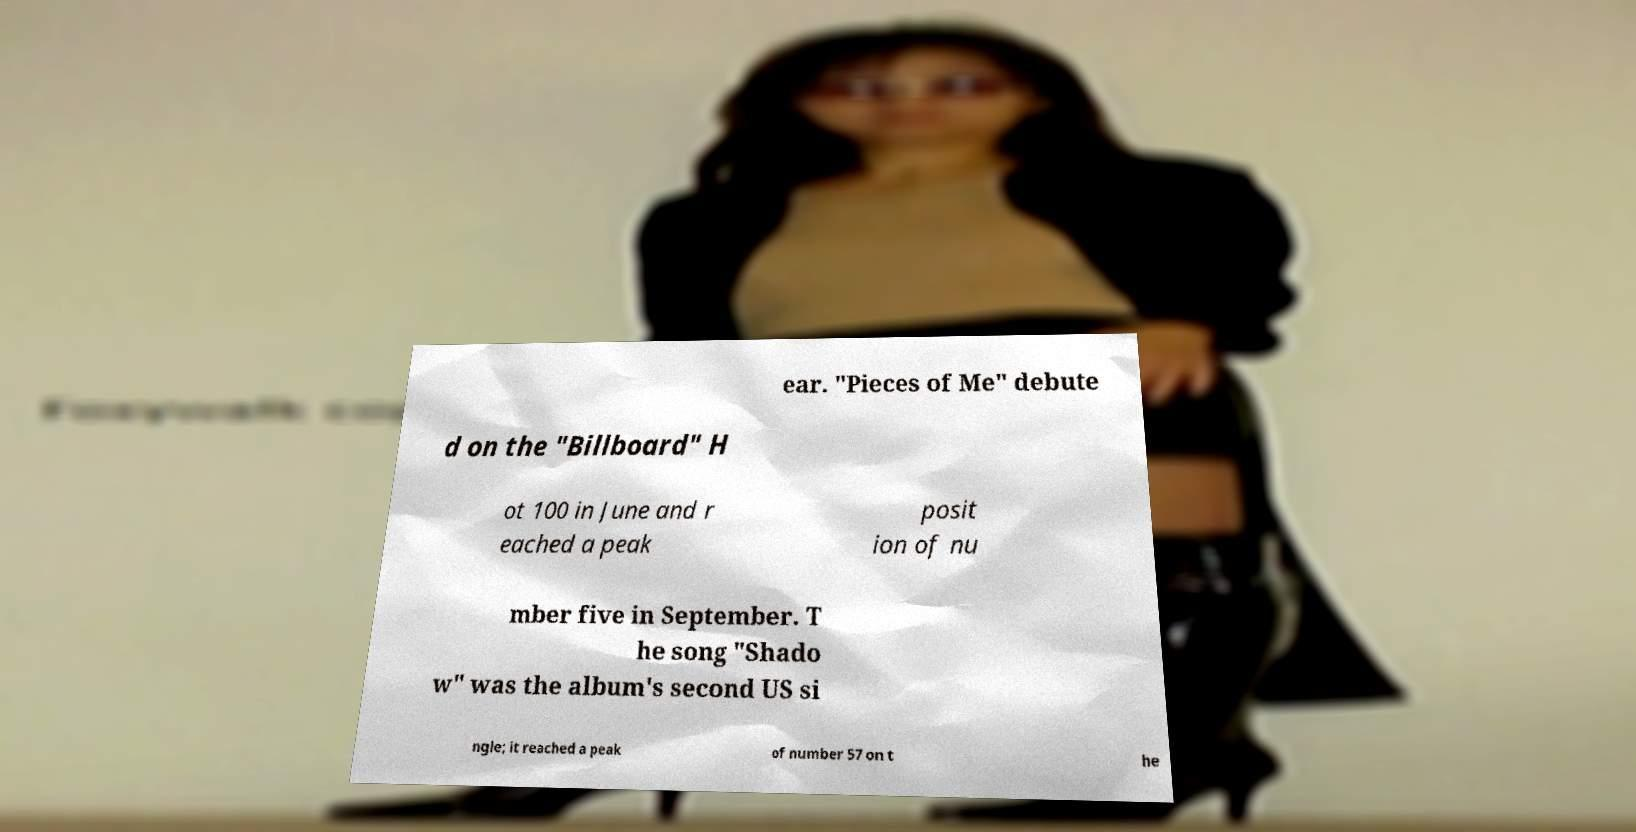What messages or text are displayed in this image? I need them in a readable, typed format. ear. "Pieces of Me" debute d on the "Billboard" H ot 100 in June and r eached a peak posit ion of nu mber five in September. T he song "Shado w" was the album's second US si ngle; it reached a peak of number 57 on t he 